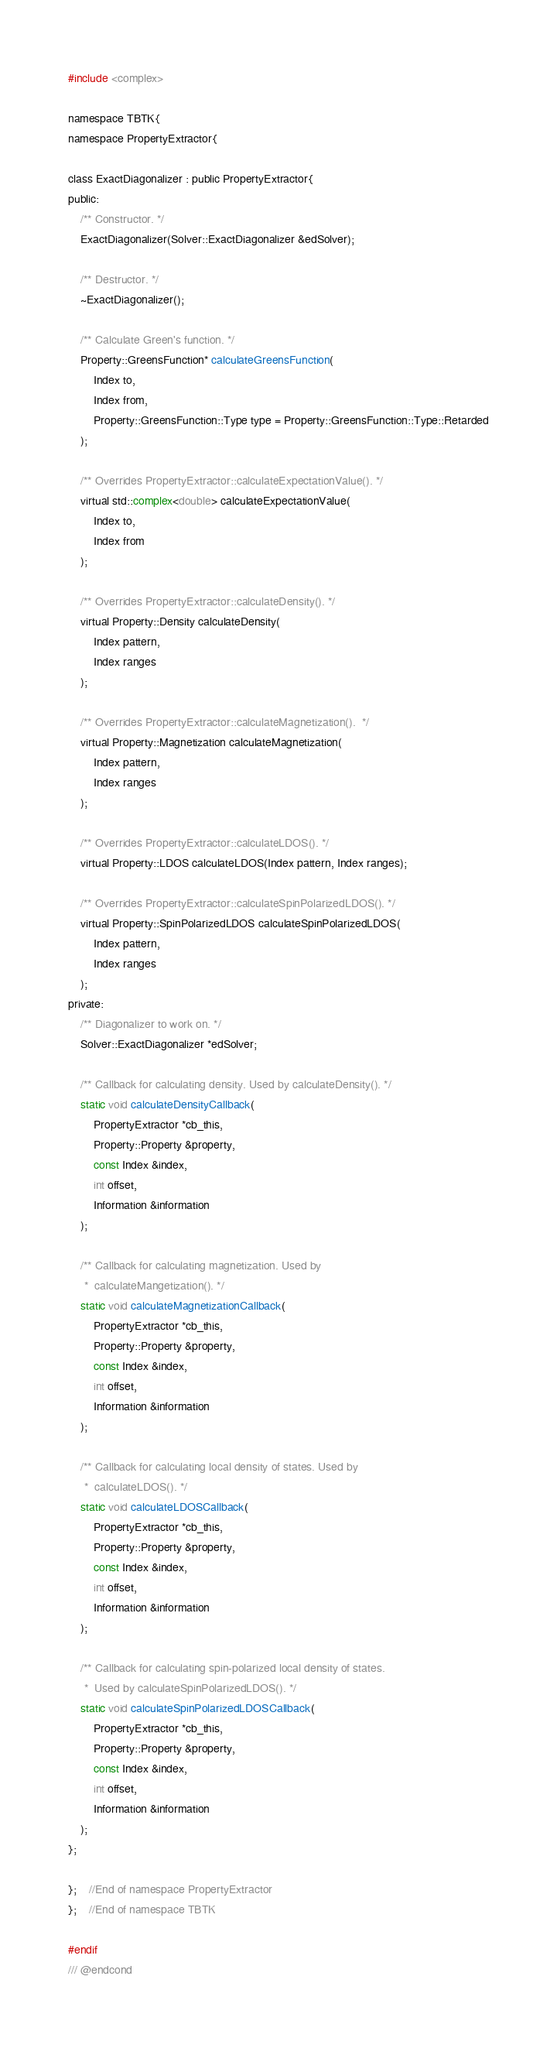<code> <loc_0><loc_0><loc_500><loc_500><_C_>#include <complex>

namespace TBTK{
namespace PropertyExtractor{

class ExactDiagonalizer : public PropertyExtractor{
public:
	/** Constructor. */
	ExactDiagonalizer(Solver::ExactDiagonalizer &edSolver);

	/** Destructor. */
	~ExactDiagonalizer();

	/** Calculate Green's function. */
	Property::GreensFunction* calculateGreensFunction(
		Index to,
		Index from,
		Property::GreensFunction::Type type = Property::GreensFunction::Type::Retarded
	);

	/** Overrides PropertyExtractor::calculateExpectationValue(). */
	virtual std::complex<double> calculateExpectationValue(
		Index to,
		Index from
	);

	/** Overrides PropertyExtractor::calculateDensity(). */
	virtual Property::Density calculateDensity(
		Index pattern,
		Index ranges
	);

	/** Overrides PropertyExtractor::calculateMagnetization().  */
	virtual Property::Magnetization calculateMagnetization(
		Index pattern,
		Index ranges
	);

	/** Overrides PropertyExtractor::calculateLDOS(). */
	virtual Property::LDOS calculateLDOS(Index pattern, Index ranges);

	/** Overrides PropertyExtractor::calculateSpinPolarizedLDOS(). */
	virtual Property::SpinPolarizedLDOS calculateSpinPolarizedLDOS(
		Index pattern,
		Index ranges
	);
private:
	/** Diagonalizer to work on. */
	Solver::ExactDiagonalizer *edSolver;

	/** Callback for calculating density. Used by calculateDensity(). */
	static void calculateDensityCallback(
		PropertyExtractor *cb_this,
		Property::Property &property,
		const Index &index,
		int offset,
		Information &information
	);

	/** Callback for calculating magnetization. Used by
	 *  calculateMangetization(). */
	static void calculateMagnetizationCallback(
		PropertyExtractor *cb_this,
		Property::Property &property,
		const Index &index,
		int offset,
		Information &information
	);

	/** Callback for calculating local density of states. Used by
	 *  calculateLDOS(). */
	static void calculateLDOSCallback(
		PropertyExtractor *cb_this,
		Property::Property &property,
		const Index &index,
		int offset,
		Information &information
	);

	/** Callback for calculating spin-polarized local density of states.
	 *  Used by calculateSpinPolarizedLDOS(). */
	static void calculateSpinPolarizedLDOSCallback(
		PropertyExtractor *cb_this,
		Property::Property &property,
		const Index &index,
		int offset,
		Information &information
	);
};

};	//End of namespace PropertyExtractor
};	//End of namespace TBTK

#endif
/// @endcond
</code> 